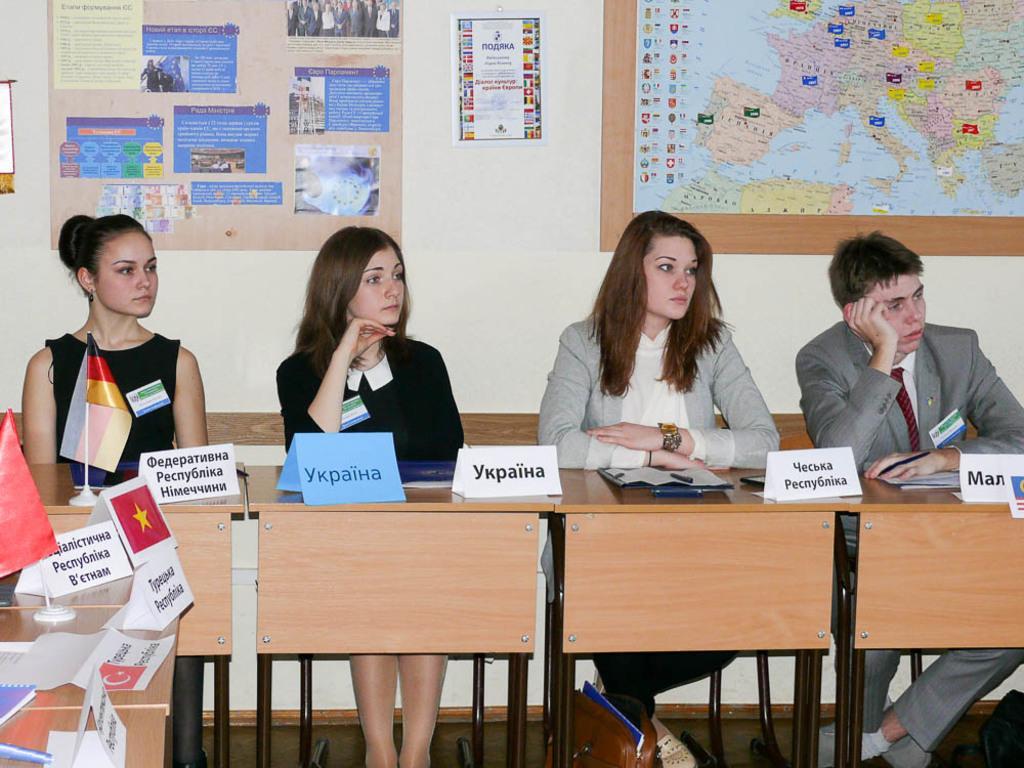How would you summarize this image in a sentence or two? In this picture we see four people seated on the bench and we see a flag on the table and a poster and a map on the wall 